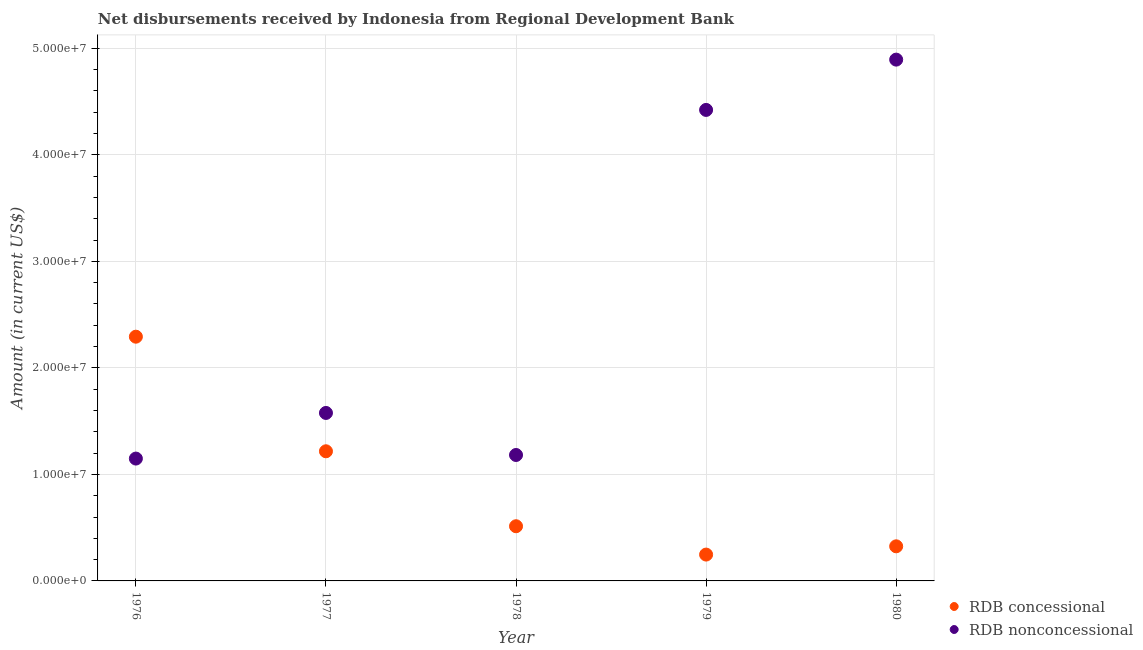How many different coloured dotlines are there?
Your answer should be very brief. 2. What is the net non concessional disbursements from rdb in 1980?
Offer a terse response. 4.89e+07. Across all years, what is the maximum net concessional disbursements from rdb?
Offer a very short reply. 2.29e+07. Across all years, what is the minimum net non concessional disbursements from rdb?
Offer a terse response. 1.15e+07. In which year was the net concessional disbursements from rdb maximum?
Make the answer very short. 1976. In which year was the net non concessional disbursements from rdb minimum?
Offer a terse response. 1976. What is the total net non concessional disbursements from rdb in the graph?
Make the answer very short. 1.32e+08. What is the difference between the net non concessional disbursements from rdb in 1979 and that in 1980?
Make the answer very short. -4.72e+06. What is the difference between the net non concessional disbursements from rdb in 1979 and the net concessional disbursements from rdb in 1978?
Make the answer very short. 3.91e+07. What is the average net non concessional disbursements from rdb per year?
Keep it short and to the point. 2.64e+07. In the year 1980, what is the difference between the net non concessional disbursements from rdb and net concessional disbursements from rdb?
Your response must be concise. 4.57e+07. In how many years, is the net non concessional disbursements from rdb greater than 22000000 US$?
Ensure brevity in your answer.  2. What is the ratio of the net non concessional disbursements from rdb in 1978 to that in 1980?
Your answer should be very brief. 0.24. Is the net non concessional disbursements from rdb in 1976 less than that in 1979?
Your answer should be very brief. Yes. Is the difference between the net concessional disbursements from rdb in 1977 and 1979 greater than the difference between the net non concessional disbursements from rdb in 1977 and 1979?
Provide a short and direct response. Yes. What is the difference between the highest and the second highest net non concessional disbursements from rdb?
Provide a succinct answer. 4.72e+06. What is the difference between the highest and the lowest net concessional disbursements from rdb?
Make the answer very short. 2.05e+07. Does the net non concessional disbursements from rdb monotonically increase over the years?
Make the answer very short. No. How many dotlines are there?
Give a very brief answer. 2. How many years are there in the graph?
Give a very brief answer. 5. What is the difference between two consecutive major ticks on the Y-axis?
Your response must be concise. 1.00e+07. Does the graph contain grids?
Your answer should be compact. Yes. Where does the legend appear in the graph?
Provide a short and direct response. Bottom right. How are the legend labels stacked?
Make the answer very short. Vertical. What is the title of the graph?
Your answer should be compact. Net disbursements received by Indonesia from Regional Development Bank. Does "Net savings(excluding particulate emission damage)" appear as one of the legend labels in the graph?
Keep it short and to the point. No. What is the label or title of the X-axis?
Your answer should be very brief. Year. What is the label or title of the Y-axis?
Offer a terse response. Amount (in current US$). What is the Amount (in current US$) in RDB concessional in 1976?
Ensure brevity in your answer.  2.29e+07. What is the Amount (in current US$) in RDB nonconcessional in 1976?
Provide a succinct answer. 1.15e+07. What is the Amount (in current US$) in RDB concessional in 1977?
Your answer should be compact. 1.22e+07. What is the Amount (in current US$) of RDB nonconcessional in 1977?
Your response must be concise. 1.58e+07. What is the Amount (in current US$) of RDB concessional in 1978?
Offer a terse response. 5.13e+06. What is the Amount (in current US$) of RDB nonconcessional in 1978?
Keep it short and to the point. 1.18e+07. What is the Amount (in current US$) in RDB concessional in 1979?
Offer a very short reply. 2.47e+06. What is the Amount (in current US$) of RDB nonconcessional in 1979?
Keep it short and to the point. 4.42e+07. What is the Amount (in current US$) in RDB concessional in 1980?
Keep it short and to the point. 3.25e+06. What is the Amount (in current US$) of RDB nonconcessional in 1980?
Your response must be concise. 4.89e+07. Across all years, what is the maximum Amount (in current US$) in RDB concessional?
Offer a terse response. 2.29e+07. Across all years, what is the maximum Amount (in current US$) of RDB nonconcessional?
Provide a short and direct response. 4.89e+07. Across all years, what is the minimum Amount (in current US$) in RDB concessional?
Your answer should be compact. 2.47e+06. Across all years, what is the minimum Amount (in current US$) in RDB nonconcessional?
Ensure brevity in your answer.  1.15e+07. What is the total Amount (in current US$) of RDB concessional in the graph?
Provide a short and direct response. 4.60e+07. What is the total Amount (in current US$) of RDB nonconcessional in the graph?
Your answer should be very brief. 1.32e+08. What is the difference between the Amount (in current US$) of RDB concessional in 1976 and that in 1977?
Your response must be concise. 1.08e+07. What is the difference between the Amount (in current US$) in RDB nonconcessional in 1976 and that in 1977?
Your answer should be compact. -4.28e+06. What is the difference between the Amount (in current US$) of RDB concessional in 1976 and that in 1978?
Make the answer very short. 1.78e+07. What is the difference between the Amount (in current US$) of RDB nonconcessional in 1976 and that in 1978?
Keep it short and to the point. -3.37e+05. What is the difference between the Amount (in current US$) of RDB concessional in 1976 and that in 1979?
Your answer should be compact. 2.05e+07. What is the difference between the Amount (in current US$) in RDB nonconcessional in 1976 and that in 1979?
Ensure brevity in your answer.  -3.27e+07. What is the difference between the Amount (in current US$) in RDB concessional in 1976 and that in 1980?
Offer a terse response. 1.97e+07. What is the difference between the Amount (in current US$) of RDB nonconcessional in 1976 and that in 1980?
Your answer should be compact. -3.75e+07. What is the difference between the Amount (in current US$) in RDB concessional in 1977 and that in 1978?
Offer a terse response. 7.04e+06. What is the difference between the Amount (in current US$) of RDB nonconcessional in 1977 and that in 1978?
Keep it short and to the point. 3.95e+06. What is the difference between the Amount (in current US$) in RDB concessional in 1977 and that in 1979?
Offer a terse response. 9.70e+06. What is the difference between the Amount (in current US$) of RDB nonconcessional in 1977 and that in 1979?
Your response must be concise. -2.84e+07. What is the difference between the Amount (in current US$) of RDB concessional in 1977 and that in 1980?
Ensure brevity in your answer.  8.92e+06. What is the difference between the Amount (in current US$) of RDB nonconcessional in 1977 and that in 1980?
Ensure brevity in your answer.  -3.32e+07. What is the difference between the Amount (in current US$) in RDB concessional in 1978 and that in 1979?
Your answer should be very brief. 2.66e+06. What is the difference between the Amount (in current US$) of RDB nonconcessional in 1978 and that in 1979?
Your response must be concise. -3.24e+07. What is the difference between the Amount (in current US$) in RDB concessional in 1978 and that in 1980?
Provide a short and direct response. 1.88e+06. What is the difference between the Amount (in current US$) of RDB nonconcessional in 1978 and that in 1980?
Ensure brevity in your answer.  -3.71e+07. What is the difference between the Amount (in current US$) of RDB concessional in 1979 and that in 1980?
Offer a very short reply. -7.76e+05. What is the difference between the Amount (in current US$) in RDB nonconcessional in 1979 and that in 1980?
Ensure brevity in your answer.  -4.72e+06. What is the difference between the Amount (in current US$) in RDB concessional in 1976 and the Amount (in current US$) in RDB nonconcessional in 1977?
Provide a succinct answer. 7.16e+06. What is the difference between the Amount (in current US$) of RDB concessional in 1976 and the Amount (in current US$) of RDB nonconcessional in 1978?
Provide a succinct answer. 1.11e+07. What is the difference between the Amount (in current US$) in RDB concessional in 1976 and the Amount (in current US$) in RDB nonconcessional in 1979?
Offer a very short reply. -2.13e+07. What is the difference between the Amount (in current US$) of RDB concessional in 1976 and the Amount (in current US$) of RDB nonconcessional in 1980?
Your answer should be very brief. -2.60e+07. What is the difference between the Amount (in current US$) of RDB concessional in 1977 and the Amount (in current US$) of RDB nonconcessional in 1978?
Keep it short and to the point. 3.48e+05. What is the difference between the Amount (in current US$) of RDB concessional in 1977 and the Amount (in current US$) of RDB nonconcessional in 1979?
Offer a terse response. -3.20e+07. What is the difference between the Amount (in current US$) of RDB concessional in 1977 and the Amount (in current US$) of RDB nonconcessional in 1980?
Your response must be concise. -3.68e+07. What is the difference between the Amount (in current US$) of RDB concessional in 1978 and the Amount (in current US$) of RDB nonconcessional in 1979?
Your response must be concise. -3.91e+07. What is the difference between the Amount (in current US$) of RDB concessional in 1978 and the Amount (in current US$) of RDB nonconcessional in 1980?
Your answer should be very brief. -4.38e+07. What is the difference between the Amount (in current US$) in RDB concessional in 1979 and the Amount (in current US$) in RDB nonconcessional in 1980?
Your answer should be very brief. -4.65e+07. What is the average Amount (in current US$) of RDB concessional per year?
Your response must be concise. 9.19e+06. What is the average Amount (in current US$) of RDB nonconcessional per year?
Your answer should be very brief. 2.64e+07. In the year 1976, what is the difference between the Amount (in current US$) in RDB concessional and Amount (in current US$) in RDB nonconcessional?
Offer a terse response. 1.14e+07. In the year 1977, what is the difference between the Amount (in current US$) in RDB concessional and Amount (in current US$) in RDB nonconcessional?
Your response must be concise. -3.60e+06. In the year 1978, what is the difference between the Amount (in current US$) of RDB concessional and Amount (in current US$) of RDB nonconcessional?
Ensure brevity in your answer.  -6.69e+06. In the year 1979, what is the difference between the Amount (in current US$) of RDB concessional and Amount (in current US$) of RDB nonconcessional?
Keep it short and to the point. -4.17e+07. In the year 1980, what is the difference between the Amount (in current US$) of RDB concessional and Amount (in current US$) of RDB nonconcessional?
Make the answer very short. -4.57e+07. What is the ratio of the Amount (in current US$) in RDB concessional in 1976 to that in 1977?
Provide a short and direct response. 1.88. What is the ratio of the Amount (in current US$) of RDB nonconcessional in 1976 to that in 1977?
Offer a terse response. 0.73. What is the ratio of the Amount (in current US$) of RDB concessional in 1976 to that in 1978?
Provide a succinct answer. 4.47. What is the ratio of the Amount (in current US$) of RDB nonconcessional in 1976 to that in 1978?
Give a very brief answer. 0.97. What is the ratio of the Amount (in current US$) in RDB concessional in 1976 to that in 1979?
Provide a succinct answer. 9.27. What is the ratio of the Amount (in current US$) in RDB nonconcessional in 1976 to that in 1979?
Offer a terse response. 0.26. What is the ratio of the Amount (in current US$) in RDB concessional in 1976 to that in 1980?
Your answer should be very brief. 7.06. What is the ratio of the Amount (in current US$) in RDB nonconcessional in 1976 to that in 1980?
Ensure brevity in your answer.  0.23. What is the ratio of the Amount (in current US$) in RDB concessional in 1977 to that in 1978?
Your response must be concise. 2.37. What is the ratio of the Amount (in current US$) in RDB nonconcessional in 1977 to that in 1978?
Make the answer very short. 1.33. What is the ratio of the Amount (in current US$) of RDB concessional in 1977 to that in 1979?
Keep it short and to the point. 4.92. What is the ratio of the Amount (in current US$) of RDB nonconcessional in 1977 to that in 1979?
Offer a terse response. 0.36. What is the ratio of the Amount (in current US$) of RDB concessional in 1977 to that in 1980?
Ensure brevity in your answer.  3.75. What is the ratio of the Amount (in current US$) of RDB nonconcessional in 1977 to that in 1980?
Offer a very short reply. 0.32. What is the ratio of the Amount (in current US$) of RDB concessional in 1978 to that in 1979?
Give a very brief answer. 2.08. What is the ratio of the Amount (in current US$) of RDB nonconcessional in 1978 to that in 1979?
Offer a terse response. 0.27. What is the ratio of the Amount (in current US$) of RDB concessional in 1978 to that in 1980?
Offer a terse response. 1.58. What is the ratio of the Amount (in current US$) of RDB nonconcessional in 1978 to that in 1980?
Offer a terse response. 0.24. What is the ratio of the Amount (in current US$) of RDB concessional in 1979 to that in 1980?
Keep it short and to the point. 0.76. What is the ratio of the Amount (in current US$) in RDB nonconcessional in 1979 to that in 1980?
Provide a short and direct response. 0.9. What is the difference between the highest and the second highest Amount (in current US$) of RDB concessional?
Offer a terse response. 1.08e+07. What is the difference between the highest and the second highest Amount (in current US$) in RDB nonconcessional?
Give a very brief answer. 4.72e+06. What is the difference between the highest and the lowest Amount (in current US$) in RDB concessional?
Give a very brief answer. 2.05e+07. What is the difference between the highest and the lowest Amount (in current US$) in RDB nonconcessional?
Make the answer very short. 3.75e+07. 